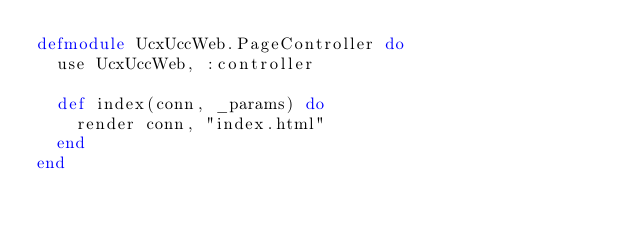<code> <loc_0><loc_0><loc_500><loc_500><_Elixir_>defmodule UcxUccWeb.PageController do
  use UcxUccWeb, :controller

  def index(conn, _params) do
    render conn, "index.html"
  end
end
</code> 